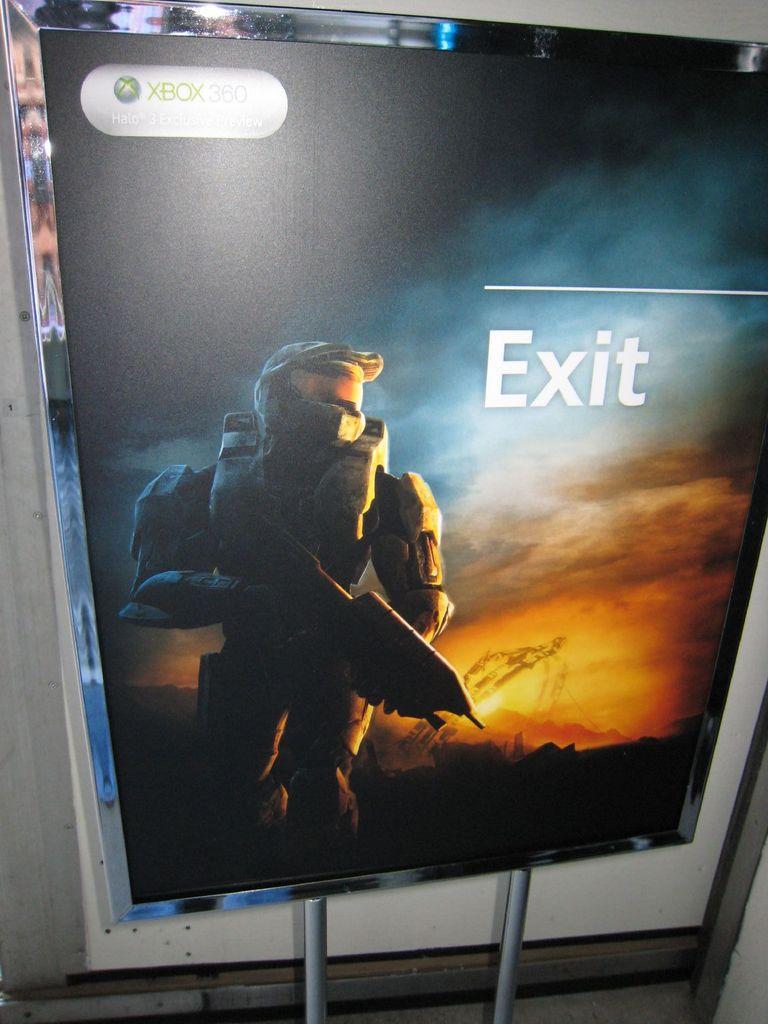What video game system is this for?
Make the answer very short. Xbox. What command is listed in large text on the screen?
Give a very brief answer. Exit. 